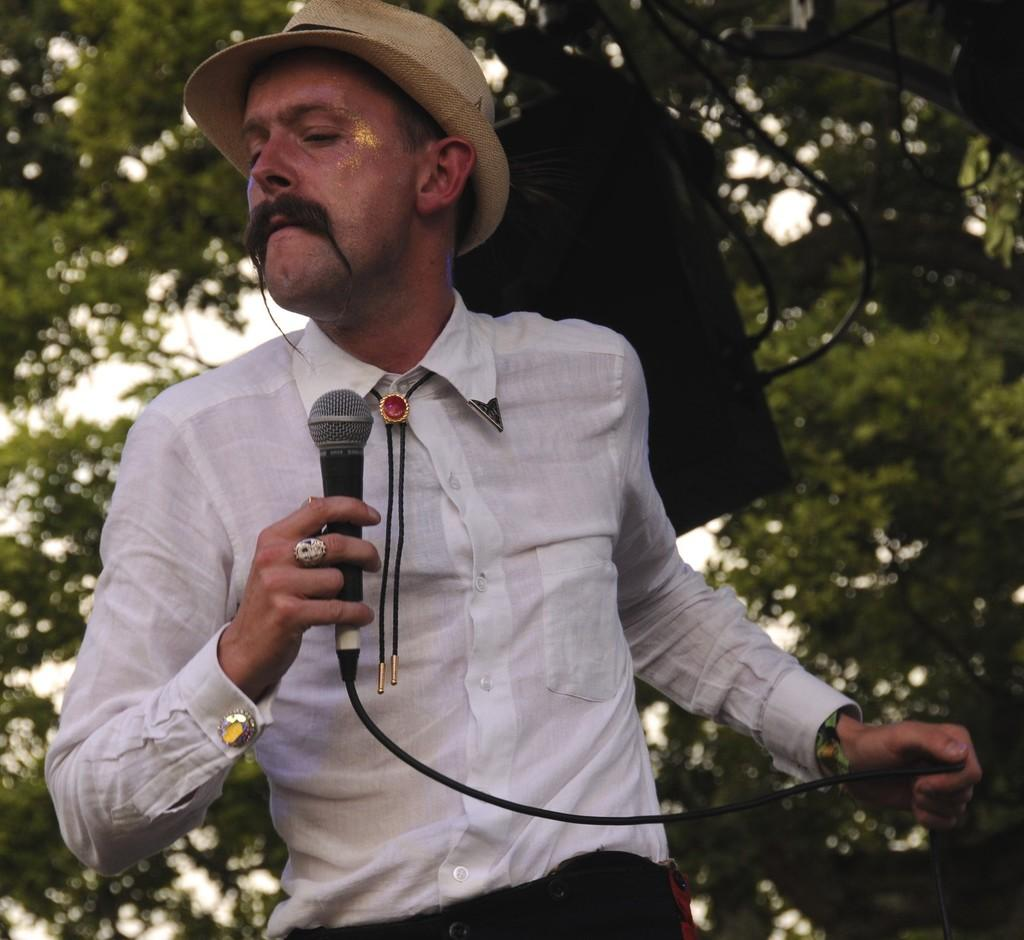Who or what is the main subject in the image? There is a person in the image. What is the person wearing on their upper body? The person is wearing a white shirt. What object is the person holding in their hand? The person is holding a microphone in their hand. What type of headwear is the person wearing? The person is wearing a cap on their head. What type of natural element can be seen behind the person? There is a tree visible behind the person. What type of basin is visible in the image? There is no basin present in the image. Is the person standing near a stove in the image? There is no stove present in the image. 